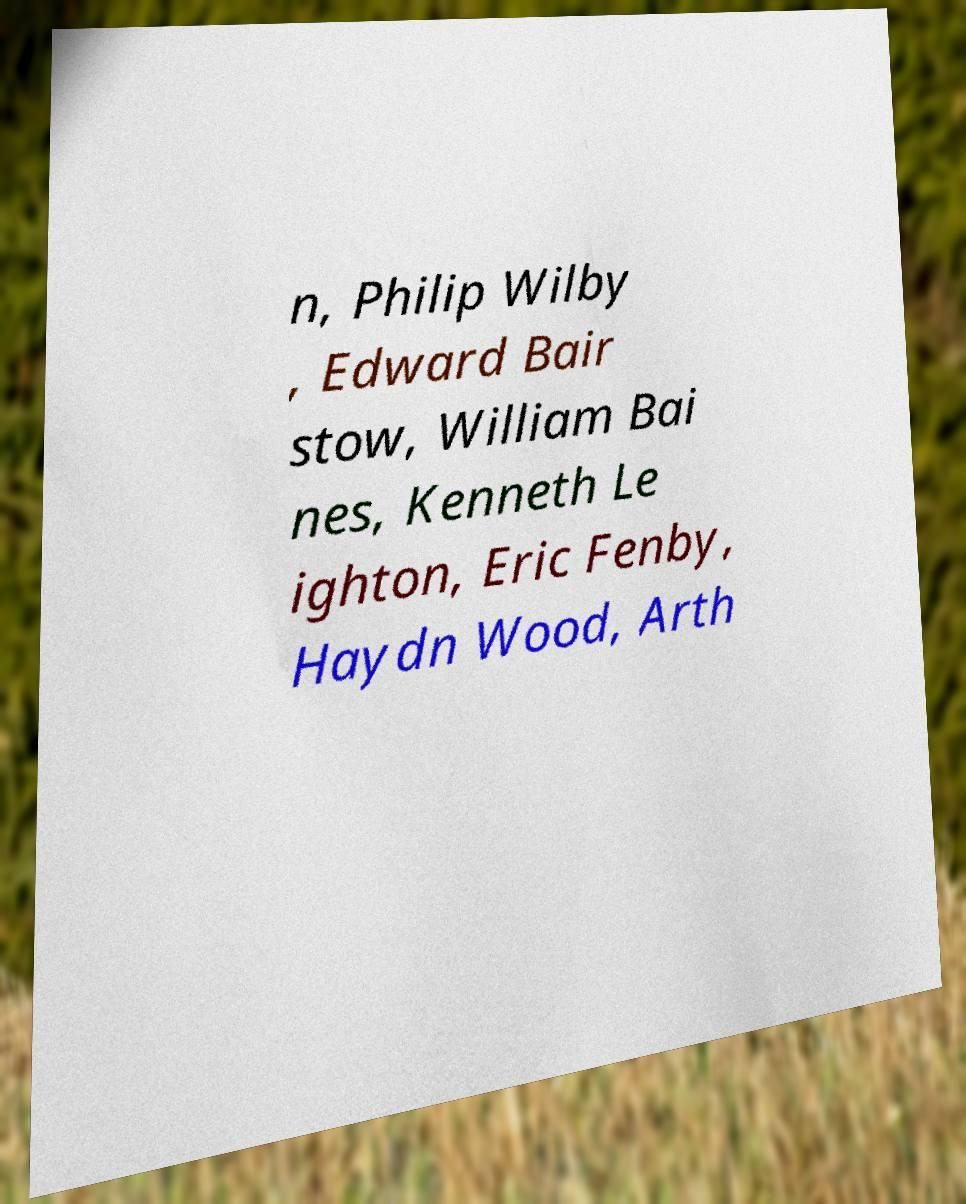Please read and relay the text visible in this image. What does it say? n, Philip Wilby , Edward Bair stow, William Bai nes, Kenneth Le ighton, Eric Fenby, Haydn Wood, Arth 